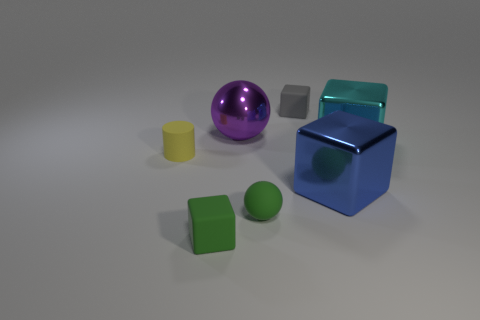Do the yellow rubber cylinder and the rubber block that is behind the cyan metallic object have the same size?
Ensure brevity in your answer.  Yes. What number of purple balls have the same size as the cyan object?
Keep it short and to the point. 1. The cylinder that is the same material as the small sphere is what color?
Offer a terse response. Yellow. Are there more green spheres than small purple metallic cubes?
Your answer should be compact. Yes. Does the small yellow object have the same material as the purple thing?
Your answer should be very brief. No. What shape is the big blue object that is made of the same material as the cyan block?
Offer a terse response. Cube. Is the number of rubber cubes less than the number of small rubber objects?
Offer a terse response. Yes. What material is the large thing that is behind the tiny yellow cylinder and right of the small ball?
Provide a short and direct response. Metal. What is the size of the matte cube on the right side of the big shiny thing left of the rubber cube behind the small yellow cylinder?
Your answer should be very brief. Small. There is a big purple metallic thing; is its shape the same as the green thing on the left side of the purple metal sphere?
Ensure brevity in your answer.  No. 